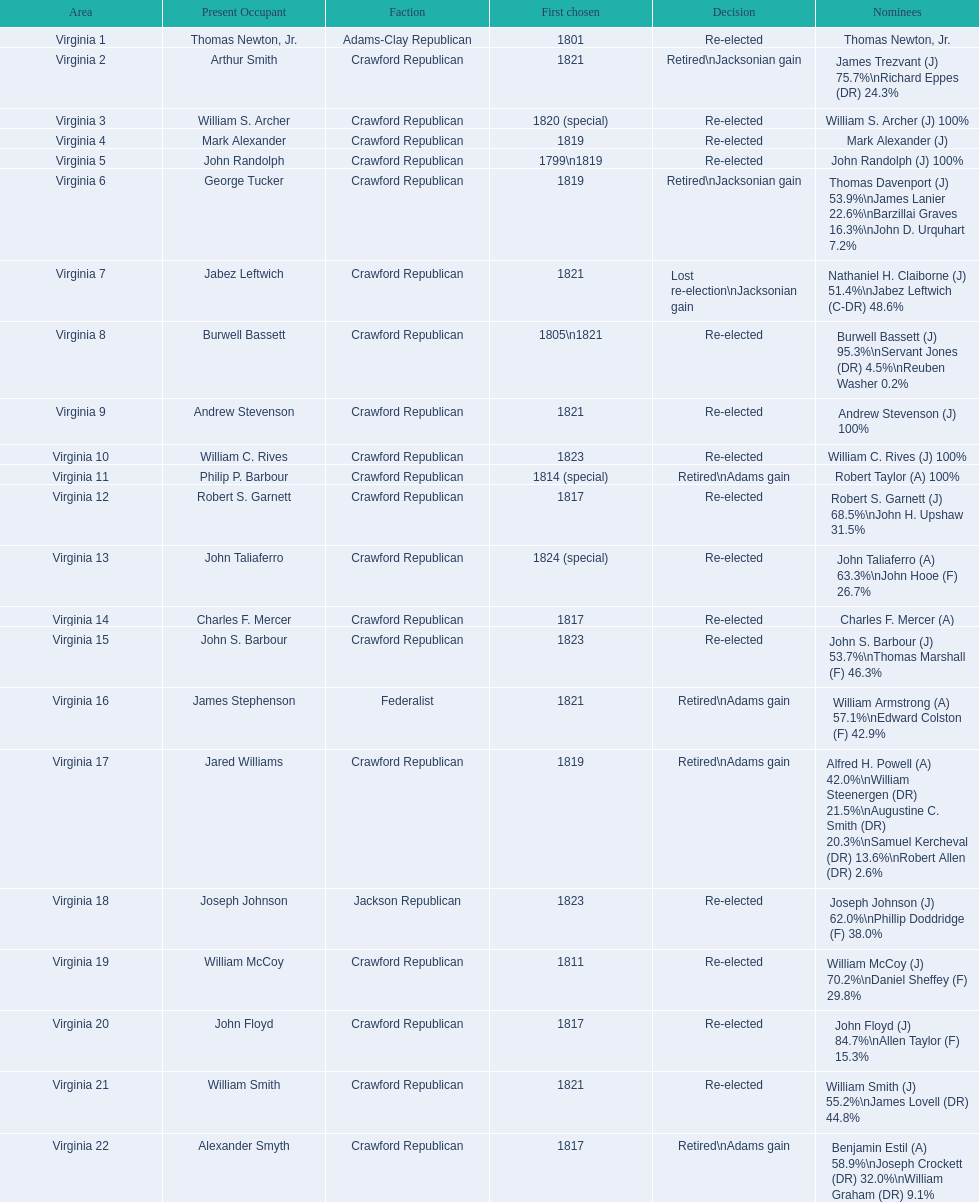Who were the incumbents of the 1824 united states house of representatives elections? Thomas Newton, Jr., Arthur Smith, William S. Archer, Mark Alexander, John Randolph, George Tucker, Jabez Leftwich, Burwell Bassett, Andrew Stevenson, William C. Rives, Philip P. Barbour, Robert S. Garnett, John Taliaferro, Charles F. Mercer, John S. Barbour, James Stephenson, Jared Williams, Joseph Johnson, William McCoy, John Floyd, William Smith, Alexander Smyth. And who were the candidates? Thomas Newton, Jr., James Trezvant (J) 75.7%\nRichard Eppes (DR) 24.3%, William S. Archer (J) 100%, Mark Alexander (J), John Randolph (J) 100%, Thomas Davenport (J) 53.9%\nJames Lanier 22.6%\nBarzillai Graves 16.3%\nJohn D. Urquhart 7.2%, Nathaniel H. Claiborne (J) 51.4%\nJabez Leftwich (C-DR) 48.6%, Burwell Bassett (J) 95.3%\nServant Jones (DR) 4.5%\nReuben Washer 0.2%, Andrew Stevenson (J) 100%, William C. Rives (J) 100%, Robert Taylor (A) 100%, Robert S. Garnett (J) 68.5%\nJohn H. Upshaw 31.5%, John Taliaferro (A) 63.3%\nJohn Hooe (F) 26.7%, Charles F. Mercer (A), John S. Barbour (J) 53.7%\nThomas Marshall (F) 46.3%, William Armstrong (A) 57.1%\nEdward Colston (F) 42.9%, Alfred H. Powell (A) 42.0%\nWilliam Steenergen (DR) 21.5%\nAugustine C. Smith (DR) 20.3%\nSamuel Kercheval (DR) 13.6%\nRobert Allen (DR) 2.6%, Joseph Johnson (J) 62.0%\nPhillip Doddridge (F) 38.0%, William McCoy (J) 70.2%\nDaniel Sheffey (F) 29.8%, John Floyd (J) 84.7%\nAllen Taylor (F) 15.3%, William Smith (J) 55.2%\nJames Lovell (DR) 44.8%, Benjamin Estil (A) 58.9%\nJoseph Crockett (DR) 32.0%\nWilliam Graham (DR) 9.1%. What were the results of their elections? Re-elected, Retired\nJacksonian gain, Re-elected, Re-elected, Re-elected, Retired\nJacksonian gain, Lost re-election\nJacksonian gain, Re-elected, Re-elected, Re-elected, Retired\nAdams gain, Re-elected, Re-elected, Re-elected, Re-elected, Retired\nAdams gain, Retired\nAdams gain, Re-elected, Re-elected, Re-elected, Re-elected, Retired\nAdams gain. And which jacksonian won over 76%? Arthur Smith. 